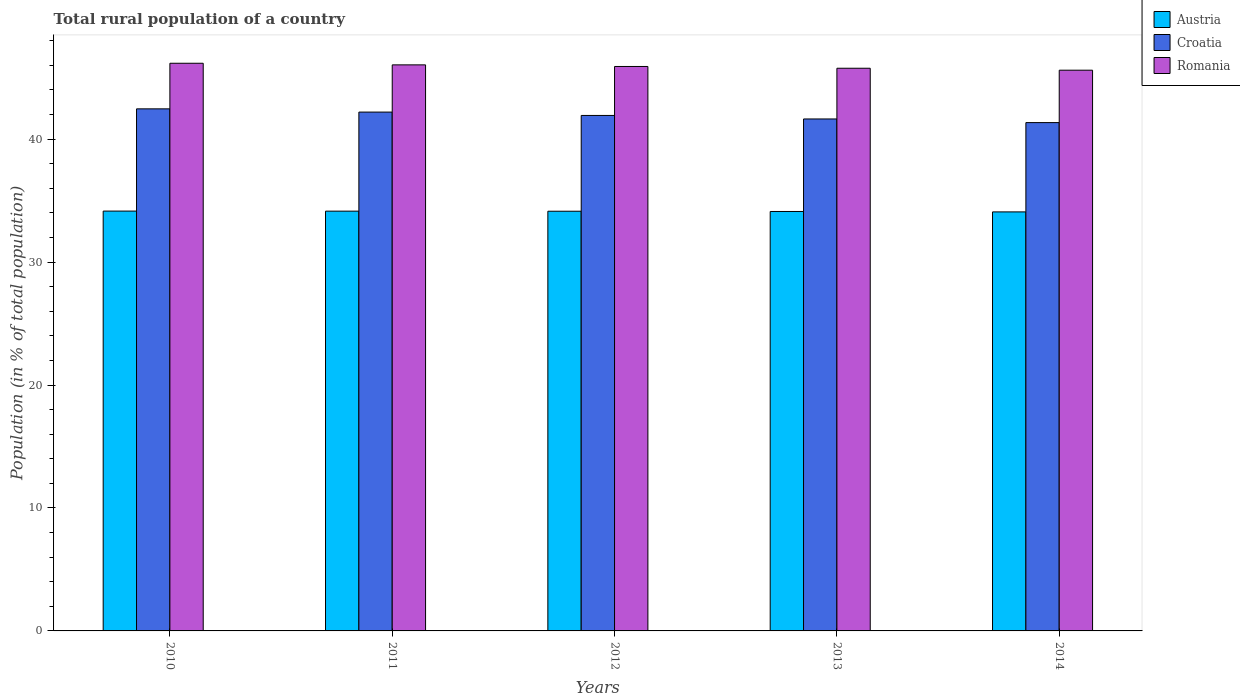How many groups of bars are there?
Your answer should be very brief. 5. How many bars are there on the 2nd tick from the right?
Provide a short and direct response. 3. What is the rural population in Austria in 2010?
Your answer should be very brief. 34.15. Across all years, what is the maximum rural population in Croatia?
Provide a succinct answer. 42.46. Across all years, what is the minimum rural population in Romania?
Offer a terse response. 45.61. In which year was the rural population in Austria maximum?
Your response must be concise. 2010. In which year was the rural population in Croatia minimum?
Give a very brief answer. 2014. What is the total rural population in Romania in the graph?
Keep it short and to the point. 229.49. What is the difference between the rural population in Croatia in 2011 and that in 2013?
Offer a terse response. 0.56. What is the difference between the rural population in Romania in 2011 and the rural population in Croatia in 2014?
Your answer should be compact. 4.7. What is the average rural population in Austria per year?
Make the answer very short. 34.12. In the year 2011, what is the difference between the rural population in Croatia and rural population in Austria?
Provide a succinct answer. 8.06. In how many years, is the rural population in Romania greater than 40 %?
Make the answer very short. 5. What is the ratio of the rural population in Romania in 2013 to that in 2014?
Offer a very short reply. 1. Is the difference between the rural population in Croatia in 2013 and 2014 greater than the difference between the rural population in Austria in 2013 and 2014?
Keep it short and to the point. Yes. What is the difference between the highest and the second highest rural population in Croatia?
Keep it short and to the point. 0.26. What is the difference between the highest and the lowest rural population in Croatia?
Provide a succinct answer. 1.12. Is the sum of the rural population in Romania in 2010 and 2012 greater than the maximum rural population in Croatia across all years?
Your answer should be compact. Yes. What does the 3rd bar from the left in 2012 represents?
Offer a terse response. Romania. What does the 2nd bar from the right in 2013 represents?
Provide a short and direct response. Croatia. How many bars are there?
Offer a very short reply. 15. Are all the bars in the graph horizontal?
Make the answer very short. No. How many years are there in the graph?
Offer a terse response. 5. What is the difference between two consecutive major ticks on the Y-axis?
Keep it short and to the point. 10. Does the graph contain grids?
Give a very brief answer. No. How many legend labels are there?
Offer a very short reply. 3. What is the title of the graph?
Your answer should be compact. Total rural population of a country. Does "Fragile and conflict affected situations" appear as one of the legend labels in the graph?
Your answer should be compact. No. What is the label or title of the X-axis?
Your answer should be compact. Years. What is the label or title of the Y-axis?
Give a very brief answer. Population (in % of total population). What is the Population (in % of total population) in Austria in 2010?
Give a very brief answer. 34.15. What is the Population (in % of total population) in Croatia in 2010?
Provide a succinct answer. 42.46. What is the Population (in % of total population) of Romania in 2010?
Offer a very short reply. 46.17. What is the Population (in % of total population) in Austria in 2011?
Offer a very short reply. 34.14. What is the Population (in % of total population) of Croatia in 2011?
Ensure brevity in your answer.  42.2. What is the Population (in % of total population) of Romania in 2011?
Make the answer very short. 46.04. What is the Population (in % of total population) of Austria in 2012?
Offer a very short reply. 34.14. What is the Population (in % of total population) in Croatia in 2012?
Give a very brief answer. 41.93. What is the Population (in % of total population) of Romania in 2012?
Your answer should be compact. 45.91. What is the Population (in % of total population) of Austria in 2013?
Offer a very short reply. 34.12. What is the Population (in % of total population) of Croatia in 2013?
Offer a very short reply. 41.64. What is the Population (in % of total population) of Romania in 2013?
Ensure brevity in your answer.  45.77. What is the Population (in % of total population) in Austria in 2014?
Your answer should be compact. 34.08. What is the Population (in % of total population) of Croatia in 2014?
Make the answer very short. 41.34. What is the Population (in % of total population) in Romania in 2014?
Your response must be concise. 45.61. Across all years, what is the maximum Population (in % of total population) in Austria?
Ensure brevity in your answer.  34.15. Across all years, what is the maximum Population (in % of total population) in Croatia?
Provide a short and direct response. 42.46. Across all years, what is the maximum Population (in % of total population) in Romania?
Ensure brevity in your answer.  46.17. Across all years, what is the minimum Population (in % of total population) in Austria?
Make the answer very short. 34.08. Across all years, what is the minimum Population (in % of total population) in Croatia?
Provide a succinct answer. 41.34. Across all years, what is the minimum Population (in % of total population) of Romania?
Your answer should be very brief. 45.61. What is the total Population (in % of total population) of Austria in the graph?
Your answer should be very brief. 170.62. What is the total Population (in % of total population) in Croatia in the graph?
Keep it short and to the point. 209.57. What is the total Population (in % of total population) of Romania in the graph?
Provide a succinct answer. 229.49. What is the difference between the Population (in % of total population) of Austria in 2010 and that in 2011?
Provide a succinct answer. 0.01. What is the difference between the Population (in % of total population) of Croatia in 2010 and that in 2011?
Your answer should be compact. 0.26. What is the difference between the Population (in % of total population) in Romania in 2010 and that in 2011?
Your answer should be very brief. 0.13. What is the difference between the Population (in % of total population) in Austria in 2010 and that in 2012?
Give a very brief answer. 0.01. What is the difference between the Population (in % of total population) of Croatia in 2010 and that in 2012?
Your answer should be compact. 0.54. What is the difference between the Population (in % of total population) of Romania in 2010 and that in 2012?
Ensure brevity in your answer.  0.26. What is the difference between the Population (in % of total population) of Austria in 2010 and that in 2013?
Offer a terse response. 0.03. What is the difference between the Population (in % of total population) in Croatia in 2010 and that in 2013?
Ensure brevity in your answer.  0.82. What is the difference between the Population (in % of total population) in Romania in 2010 and that in 2013?
Give a very brief answer. 0.41. What is the difference between the Population (in % of total population) of Austria in 2010 and that in 2014?
Your answer should be compact. 0.07. What is the difference between the Population (in % of total population) in Croatia in 2010 and that in 2014?
Give a very brief answer. 1.12. What is the difference between the Population (in % of total population) in Romania in 2010 and that in 2014?
Offer a very short reply. 0.56. What is the difference between the Population (in % of total population) of Austria in 2011 and that in 2012?
Offer a very short reply. 0.01. What is the difference between the Population (in % of total population) of Croatia in 2011 and that in 2012?
Keep it short and to the point. 0.27. What is the difference between the Population (in % of total population) of Romania in 2011 and that in 2012?
Provide a succinct answer. 0.13. What is the difference between the Population (in % of total population) of Austria in 2011 and that in 2013?
Make the answer very short. 0.03. What is the difference between the Population (in % of total population) of Croatia in 2011 and that in 2013?
Ensure brevity in your answer.  0.56. What is the difference between the Population (in % of total population) in Romania in 2011 and that in 2013?
Ensure brevity in your answer.  0.28. What is the difference between the Population (in % of total population) in Austria in 2011 and that in 2014?
Your answer should be compact. 0.06. What is the difference between the Population (in % of total population) in Croatia in 2011 and that in 2014?
Your response must be concise. 0.86. What is the difference between the Population (in % of total population) in Romania in 2011 and that in 2014?
Provide a succinct answer. 0.43. What is the difference between the Population (in % of total population) of Austria in 2012 and that in 2013?
Make the answer very short. 0.02. What is the difference between the Population (in % of total population) of Croatia in 2012 and that in 2013?
Your answer should be compact. 0.28. What is the difference between the Population (in % of total population) of Romania in 2012 and that in 2013?
Give a very brief answer. 0.14. What is the difference between the Population (in % of total population) of Austria in 2012 and that in 2014?
Give a very brief answer. 0.06. What is the difference between the Population (in % of total population) of Croatia in 2012 and that in 2014?
Your response must be concise. 0.58. What is the difference between the Population (in % of total population) of Romania in 2012 and that in 2014?
Your answer should be compact. 0.3. What is the difference between the Population (in % of total population) of Austria in 2013 and that in 2014?
Keep it short and to the point. 0.04. What is the difference between the Population (in % of total population) of Croatia in 2013 and that in 2014?
Offer a terse response. 0.3. What is the difference between the Population (in % of total population) of Romania in 2013 and that in 2014?
Your answer should be compact. 0.16. What is the difference between the Population (in % of total population) of Austria in 2010 and the Population (in % of total population) of Croatia in 2011?
Give a very brief answer. -8.05. What is the difference between the Population (in % of total population) of Austria in 2010 and the Population (in % of total population) of Romania in 2011?
Ensure brevity in your answer.  -11.89. What is the difference between the Population (in % of total population) of Croatia in 2010 and the Population (in % of total population) of Romania in 2011?
Offer a very short reply. -3.58. What is the difference between the Population (in % of total population) of Austria in 2010 and the Population (in % of total population) of Croatia in 2012?
Ensure brevity in your answer.  -7.78. What is the difference between the Population (in % of total population) of Austria in 2010 and the Population (in % of total population) of Romania in 2012?
Make the answer very short. -11.76. What is the difference between the Population (in % of total population) of Croatia in 2010 and the Population (in % of total population) of Romania in 2012?
Provide a succinct answer. -3.45. What is the difference between the Population (in % of total population) of Austria in 2010 and the Population (in % of total population) of Croatia in 2013?
Provide a succinct answer. -7.49. What is the difference between the Population (in % of total population) of Austria in 2010 and the Population (in % of total population) of Romania in 2013?
Offer a terse response. -11.62. What is the difference between the Population (in % of total population) of Croatia in 2010 and the Population (in % of total population) of Romania in 2013?
Offer a very short reply. -3.3. What is the difference between the Population (in % of total population) of Austria in 2010 and the Population (in % of total population) of Croatia in 2014?
Your answer should be very brief. -7.2. What is the difference between the Population (in % of total population) of Austria in 2010 and the Population (in % of total population) of Romania in 2014?
Offer a terse response. -11.46. What is the difference between the Population (in % of total population) in Croatia in 2010 and the Population (in % of total population) in Romania in 2014?
Your response must be concise. -3.14. What is the difference between the Population (in % of total population) of Austria in 2011 and the Population (in % of total population) of Croatia in 2012?
Your response must be concise. -7.78. What is the difference between the Population (in % of total population) of Austria in 2011 and the Population (in % of total population) of Romania in 2012?
Offer a terse response. -11.77. What is the difference between the Population (in % of total population) of Croatia in 2011 and the Population (in % of total population) of Romania in 2012?
Offer a very short reply. -3.71. What is the difference between the Population (in % of total population) of Austria in 2011 and the Population (in % of total population) of Croatia in 2013?
Your answer should be very brief. -7.5. What is the difference between the Population (in % of total population) of Austria in 2011 and the Population (in % of total population) of Romania in 2013?
Ensure brevity in your answer.  -11.62. What is the difference between the Population (in % of total population) in Croatia in 2011 and the Population (in % of total population) in Romania in 2013?
Your answer should be compact. -3.56. What is the difference between the Population (in % of total population) of Austria in 2011 and the Population (in % of total population) of Croatia in 2014?
Ensure brevity in your answer.  -7.2. What is the difference between the Population (in % of total population) in Austria in 2011 and the Population (in % of total population) in Romania in 2014?
Give a very brief answer. -11.46. What is the difference between the Population (in % of total population) of Croatia in 2011 and the Population (in % of total population) of Romania in 2014?
Give a very brief answer. -3.41. What is the difference between the Population (in % of total population) in Austria in 2012 and the Population (in % of total population) in Croatia in 2013?
Make the answer very short. -7.5. What is the difference between the Population (in % of total population) in Austria in 2012 and the Population (in % of total population) in Romania in 2013?
Keep it short and to the point. -11.63. What is the difference between the Population (in % of total population) in Croatia in 2012 and the Population (in % of total population) in Romania in 2013?
Offer a very short reply. -3.84. What is the difference between the Population (in % of total population) of Austria in 2012 and the Population (in % of total population) of Croatia in 2014?
Offer a terse response. -7.21. What is the difference between the Population (in % of total population) in Austria in 2012 and the Population (in % of total population) in Romania in 2014?
Provide a short and direct response. -11.47. What is the difference between the Population (in % of total population) of Croatia in 2012 and the Population (in % of total population) of Romania in 2014?
Offer a very short reply. -3.68. What is the difference between the Population (in % of total population) in Austria in 2013 and the Population (in % of total population) in Croatia in 2014?
Ensure brevity in your answer.  -7.23. What is the difference between the Population (in % of total population) of Austria in 2013 and the Population (in % of total population) of Romania in 2014?
Your response must be concise. -11.49. What is the difference between the Population (in % of total population) of Croatia in 2013 and the Population (in % of total population) of Romania in 2014?
Provide a short and direct response. -3.97. What is the average Population (in % of total population) of Austria per year?
Your answer should be very brief. 34.12. What is the average Population (in % of total population) in Croatia per year?
Ensure brevity in your answer.  41.91. What is the average Population (in % of total population) in Romania per year?
Your response must be concise. 45.9. In the year 2010, what is the difference between the Population (in % of total population) in Austria and Population (in % of total population) in Croatia?
Your response must be concise. -8.31. In the year 2010, what is the difference between the Population (in % of total population) of Austria and Population (in % of total population) of Romania?
Provide a short and direct response. -12.02. In the year 2010, what is the difference between the Population (in % of total population) in Croatia and Population (in % of total population) in Romania?
Provide a short and direct response. -3.71. In the year 2011, what is the difference between the Population (in % of total population) in Austria and Population (in % of total population) in Croatia?
Offer a very short reply. -8.06. In the year 2011, what is the difference between the Population (in % of total population) in Austria and Population (in % of total population) in Romania?
Your answer should be compact. -11.9. In the year 2011, what is the difference between the Population (in % of total population) in Croatia and Population (in % of total population) in Romania?
Ensure brevity in your answer.  -3.84. In the year 2012, what is the difference between the Population (in % of total population) of Austria and Population (in % of total population) of Croatia?
Provide a short and direct response. -7.79. In the year 2012, what is the difference between the Population (in % of total population) in Austria and Population (in % of total population) in Romania?
Make the answer very short. -11.77. In the year 2012, what is the difference between the Population (in % of total population) of Croatia and Population (in % of total population) of Romania?
Your response must be concise. -3.98. In the year 2013, what is the difference between the Population (in % of total population) of Austria and Population (in % of total population) of Croatia?
Provide a succinct answer. -7.53. In the year 2013, what is the difference between the Population (in % of total population) of Austria and Population (in % of total population) of Romania?
Ensure brevity in your answer.  -11.65. In the year 2013, what is the difference between the Population (in % of total population) in Croatia and Population (in % of total population) in Romania?
Your answer should be very brief. -4.12. In the year 2014, what is the difference between the Population (in % of total population) of Austria and Population (in % of total population) of Croatia?
Give a very brief answer. -7.26. In the year 2014, what is the difference between the Population (in % of total population) in Austria and Population (in % of total population) in Romania?
Your answer should be very brief. -11.53. In the year 2014, what is the difference between the Population (in % of total population) in Croatia and Population (in % of total population) in Romania?
Your answer should be compact. -4.26. What is the ratio of the Population (in % of total population) in Croatia in 2010 to that in 2011?
Your response must be concise. 1.01. What is the ratio of the Population (in % of total population) in Croatia in 2010 to that in 2012?
Your answer should be compact. 1.01. What is the ratio of the Population (in % of total population) of Romania in 2010 to that in 2012?
Provide a succinct answer. 1.01. What is the ratio of the Population (in % of total population) in Croatia in 2010 to that in 2013?
Your response must be concise. 1.02. What is the ratio of the Population (in % of total population) of Romania in 2010 to that in 2013?
Offer a very short reply. 1.01. What is the ratio of the Population (in % of total population) of Croatia in 2010 to that in 2014?
Make the answer very short. 1.03. What is the ratio of the Population (in % of total population) of Romania in 2010 to that in 2014?
Keep it short and to the point. 1.01. What is the ratio of the Population (in % of total population) in Austria in 2011 to that in 2012?
Make the answer very short. 1. What is the ratio of the Population (in % of total population) of Croatia in 2011 to that in 2012?
Provide a succinct answer. 1.01. What is the ratio of the Population (in % of total population) in Croatia in 2011 to that in 2013?
Your answer should be very brief. 1.01. What is the ratio of the Population (in % of total population) of Austria in 2011 to that in 2014?
Offer a very short reply. 1. What is the ratio of the Population (in % of total population) in Croatia in 2011 to that in 2014?
Your answer should be compact. 1.02. What is the ratio of the Population (in % of total population) in Romania in 2011 to that in 2014?
Offer a terse response. 1.01. What is the ratio of the Population (in % of total population) in Croatia in 2012 to that in 2013?
Keep it short and to the point. 1.01. What is the ratio of the Population (in % of total population) in Austria in 2012 to that in 2014?
Your answer should be compact. 1. What is the ratio of the Population (in % of total population) in Croatia in 2012 to that in 2014?
Your answer should be compact. 1.01. What is the ratio of the Population (in % of total population) in Romania in 2012 to that in 2014?
Offer a very short reply. 1.01. What is the ratio of the Population (in % of total population) in Romania in 2013 to that in 2014?
Keep it short and to the point. 1. What is the difference between the highest and the second highest Population (in % of total population) of Austria?
Your response must be concise. 0.01. What is the difference between the highest and the second highest Population (in % of total population) in Croatia?
Ensure brevity in your answer.  0.26. What is the difference between the highest and the second highest Population (in % of total population) in Romania?
Offer a very short reply. 0.13. What is the difference between the highest and the lowest Population (in % of total population) of Austria?
Give a very brief answer. 0.07. What is the difference between the highest and the lowest Population (in % of total population) in Croatia?
Keep it short and to the point. 1.12. What is the difference between the highest and the lowest Population (in % of total population) in Romania?
Offer a very short reply. 0.56. 